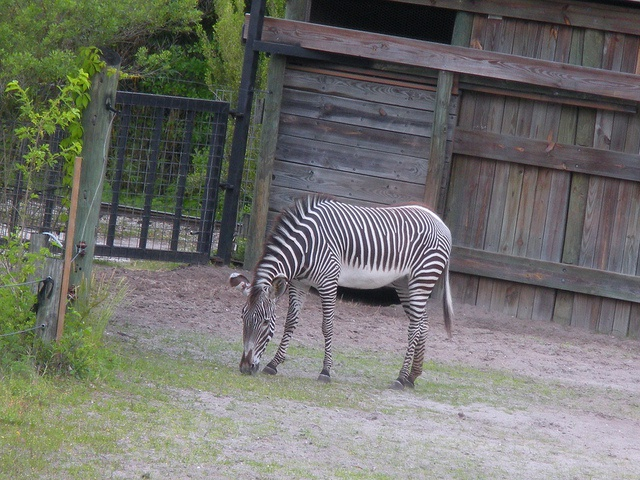Describe the objects in this image and their specific colors. I can see a zebra in darkgreen, gray, darkgray, lavender, and black tones in this image. 